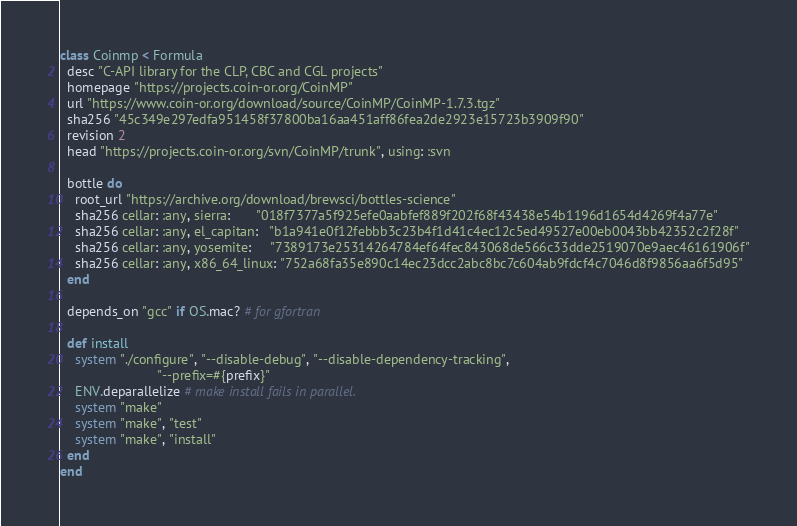<code> <loc_0><loc_0><loc_500><loc_500><_Ruby_>class Coinmp < Formula
  desc "C-API library for the CLP, CBC and CGL projects"
  homepage "https://projects.coin-or.org/CoinMP"
  url "https://www.coin-or.org/download/source/CoinMP/CoinMP-1.7.3.tgz"
  sha256 "45c349e297edfa951458f37800ba16aa451aff86fea2de2923e15723b3909f90"
  revision 2
  head "https://projects.coin-or.org/svn/CoinMP/trunk", using: :svn

  bottle do
    root_url "https://archive.org/download/brewsci/bottles-science"
    sha256 cellar: :any, sierra:       "018f7377a5f925efe0aabfef889f202f68f43438e54b1196d1654d4269f4a77e"
    sha256 cellar: :any, el_capitan:   "b1a941e0f12febbb3c23b4f1d41c4ec12c5ed49527e00eb0043bb42352c2f28f"
    sha256 cellar: :any, yosemite:     "7389173e25314264784ef64fec843068de566c33dde2519070e9aec46161906f"
    sha256 cellar: :any, x86_64_linux: "752a68fa35e890c14ec23dcc2abc8bc7c604ab9fdcf4c7046d8f9856aa6f5d95"
  end

  depends_on "gcc" if OS.mac? # for gfortran

  def install
    system "./configure", "--disable-debug", "--disable-dependency-tracking",
                          "--prefix=#{prefix}"
    ENV.deparallelize # make install fails in parallel.
    system "make"
    system "make", "test"
    system "make", "install"
  end
end
</code> 